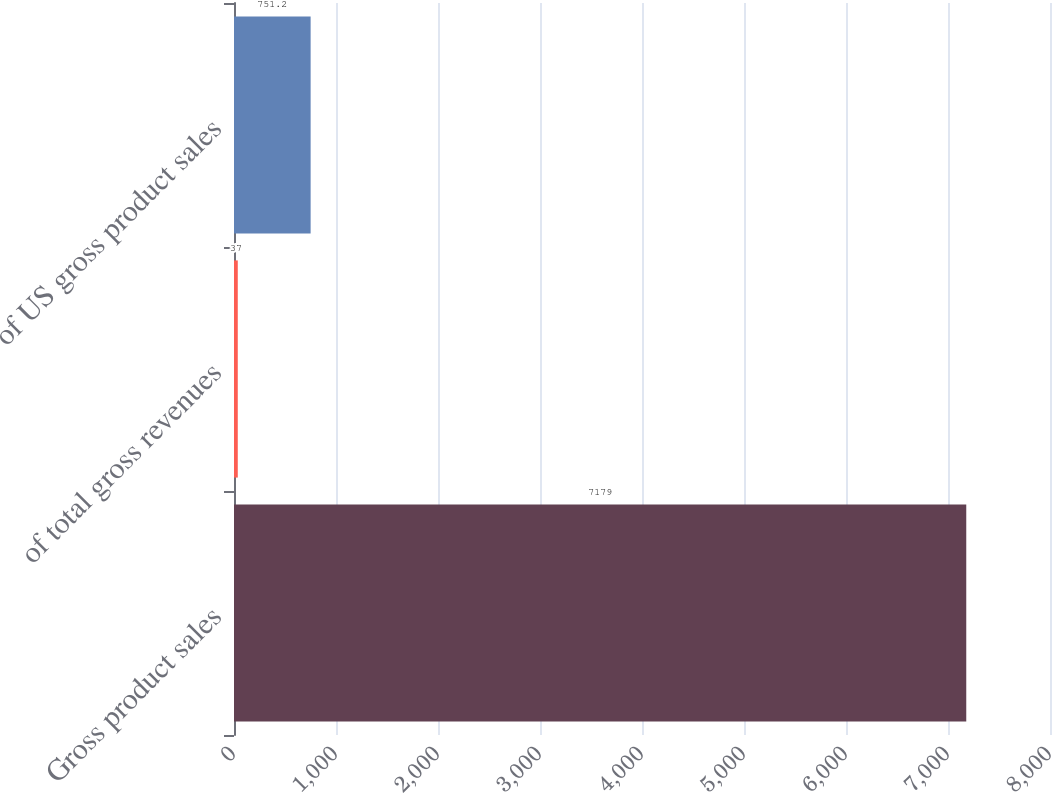Convert chart to OTSL. <chart><loc_0><loc_0><loc_500><loc_500><bar_chart><fcel>Gross product sales<fcel>of total gross revenues<fcel>of US gross product sales<nl><fcel>7179<fcel>37<fcel>751.2<nl></chart> 